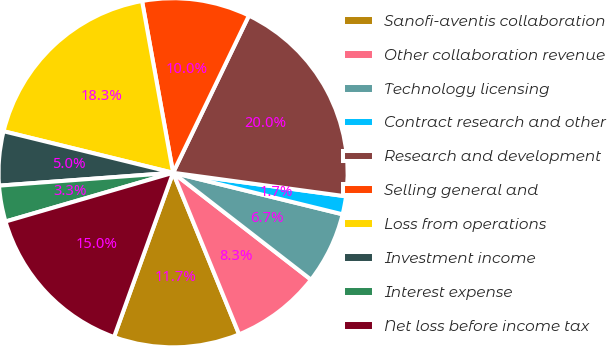Convert chart to OTSL. <chart><loc_0><loc_0><loc_500><loc_500><pie_chart><fcel>Sanofi-aventis collaboration<fcel>Other collaboration revenue<fcel>Technology licensing<fcel>Contract research and other<fcel>Research and development<fcel>Selling general and<fcel>Loss from operations<fcel>Investment income<fcel>Interest expense<fcel>Net loss before income tax<nl><fcel>11.67%<fcel>8.33%<fcel>6.67%<fcel>1.67%<fcel>20.0%<fcel>10.0%<fcel>18.33%<fcel>5.0%<fcel>3.33%<fcel>15.0%<nl></chart> 